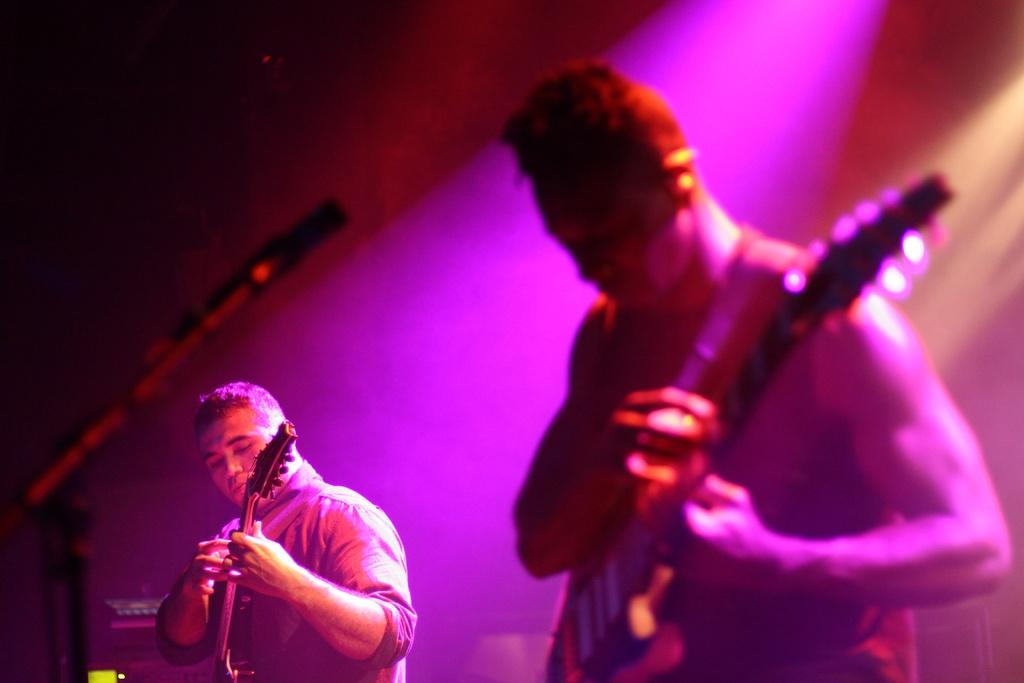How many people are in the image? There are two people in the image. What are the two people doing? The two people are playing guitars. What object is in front of the people? There is a microphone in front of the people. What can be seen behind the people}? There are objects visible behind the people. What type of mint can be seen growing behind the people in the image? There is no mint visible in the image; only objects are mentioned as being behind the people. 